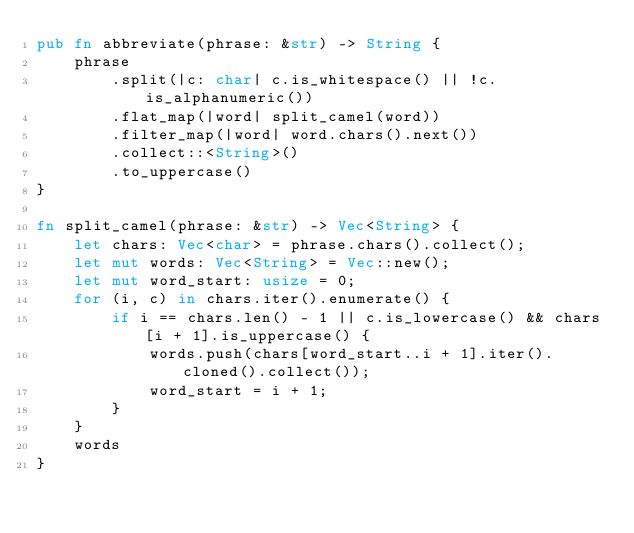<code> <loc_0><loc_0><loc_500><loc_500><_Rust_>pub fn abbreviate(phrase: &str) -> String {
    phrase
        .split(|c: char| c.is_whitespace() || !c.is_alphanumeric())
        .flat_map(|word| split_camel(word))
        .filter_map(|word| word.chars().next())
        .collect::<String>()
        .to_uppercase()
}

fn split_camel(phrase: &str) -> Vec<String> {
    let chars: Vec<char> = phrase.chars().collect();
    let mut words: Vec<String> = Vec::new();
    let mut word_start: usize = 0;
    for (i, c) in chars.iter().enumerate() {
        if i == chars.len() - 1 || c.is_lowercase() && chars[i + 1].is_uppercase() {
            words.push(chars[word_start..i + 1].iter().cloned().collect());
            word_start = i + 1;
        }
    }
    words
}
</code> 